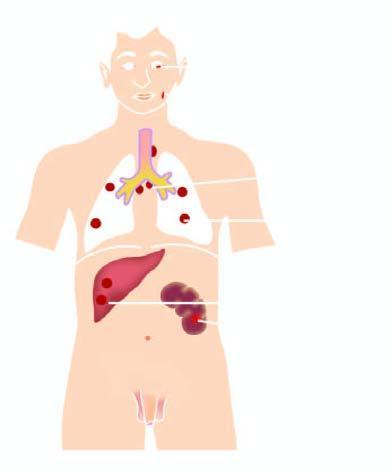re the nuclei predominantly seen in lymph nodes and throughout lung parenchyma?
Answer the question using a single word or phrase. No 